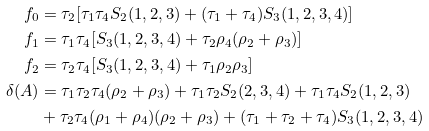<formula> <loc_0><loc_0><loc_500><loc_500>f _ { 0 } & = \tau _ { 2 } [ \tau _ { 1 } \tau _ { 4 } S _ { 2 } ( 1 , 2 , 3 ) + ( \tau _ { 1 } + \tau _ { 4 } ) S _ { 3 } ( 1 , 2 , 3 , 4 ) ] \\ f _ { 1 } & = \tau _ { 1 } \tau _ { 4 } [ S _ { 3 } ( 1 , 2 , 3 , 4 ) + \tau _ { 2 } \rho _ { 4 } ( \rho _ { 2 } + \rho _ { 3 } ) ] \\ f _ { 2 } & = \tau _ { 2 } \tau _ { 4 } [ S _ { 3 } ( 1 , 2 , 3 , 4 ) + \tau _ { 1 } \rho _ { 2 } \rho _ { 3 } ] \\ \delta ( A ) & = \tau _ { 1 } \tau _ { 2 } \tau _ { 4 } ( \rho _ { 2 } + \rho _ { 3 } ) + \tau _ { 1 } \tau _ { 2 } S _ { 2 } ( 2 , 3 , 4 ) + \tau _ { 1 } \tau _ { 4 } S _ { 2 } ( 1 , 2 , 3 ) \\ & + \tau _ { 2 } \tau _ { 4 } ( \rho _ { 1 } + \rho _ { 4 } ) ( \rho _ { 2 } + \rho _ { 3 } ) + ( \tau _ { 1 } + \tau _ { 2 } + \tau _ { 4 } ) S _ { 3 } ( 1 , 2 , 3 , 4 )</formula> 